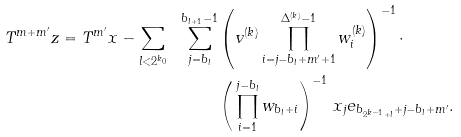Convert formula to latex. <formula><loc_0><loc_0><loc_500><loc_500>T ^ { m + m ^ { \prime } } z = T ^ { m ^ { \prime } } x - \sum _ { l < 2 ^ { k _ { 0 } } } \ \sum _ { j = b _ { l } } ^ { b _ { l + 1 } - 1 } & \left ( v ^ { ( k ) } \prod _ { i = j - b _ { l } + m ^ { \prime } + 1 } ^ { \Delta ^ { ( k ) } - 1 } w _ { i } ^ { ( k ) } \right ) ^ { - 1 } \cdot \\ & \left ( \, \prod _ { i = 1 } ^ { j - b _ { l } } w _ { b _ { l } + i } \right ) ^ { - 1 } \, x _ { j } e _ { b _ { 2 ^ { k - 1 } + l } + j - b _ { l } + m ^ { \prime } } .</formula> 